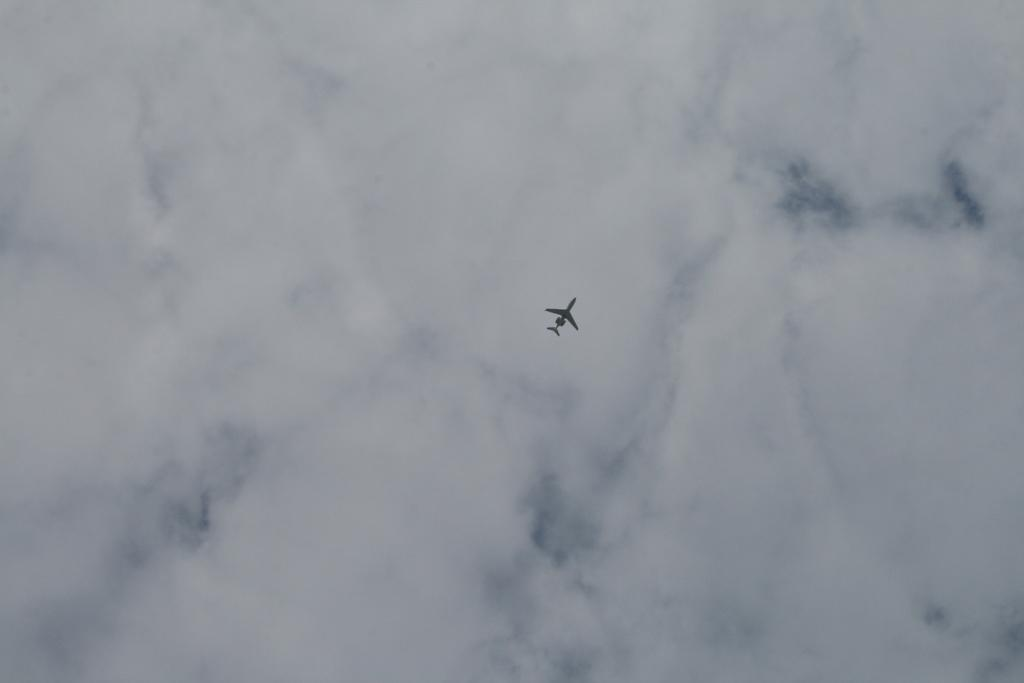What is the main subject of the image? The main subject of the image is a plane. Where is the plane located in the image? The plane is flying high in the air. What can be seen in the background of the image? There is a sky visible in the image. What is the condition of the sky in the image? The sky is full of clouds. What type of summer clothing can be seen on the passengers in the image? There are no passengers visible in the image, and therefore no clothing can be observed. 